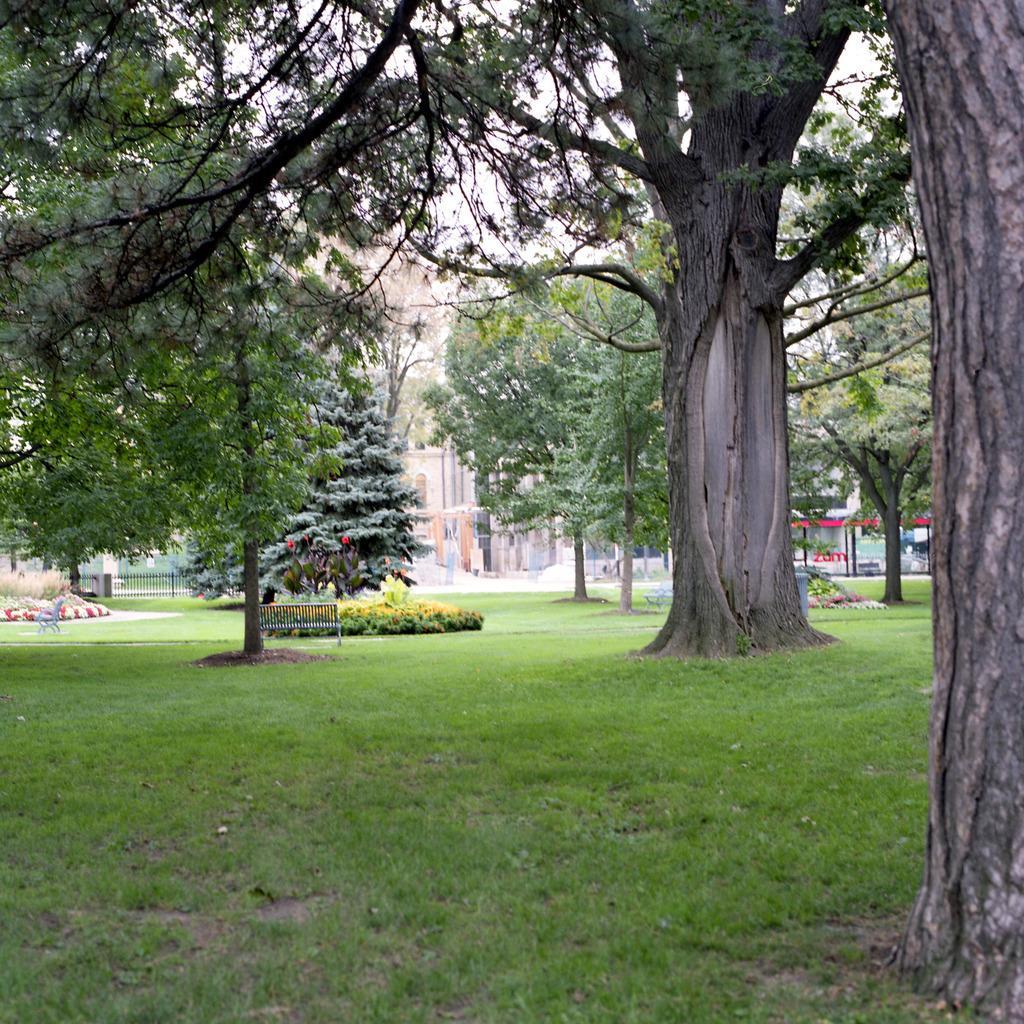Describe this image in one or two sentences. In this image I can see an open grass ground and on it I can see number of trees, number of plants and two benches. In the background I can see few buildings, the iron fence on the left side and the sky. 